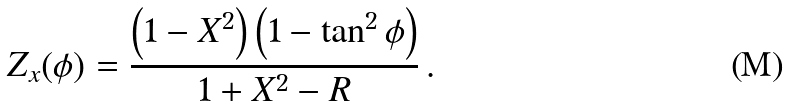Convert formula to latex. <formula><loc_0><loc_0><loc_500><loc_500>Z _ { x } ( \phi ) = \frac { \left ( 1 - X ^ { 2 } \right ) \left ( 1 - \tan ^ { 2 } \phi \right ) } { 1 + X ^ { 2 } - R } \, .</formula> 